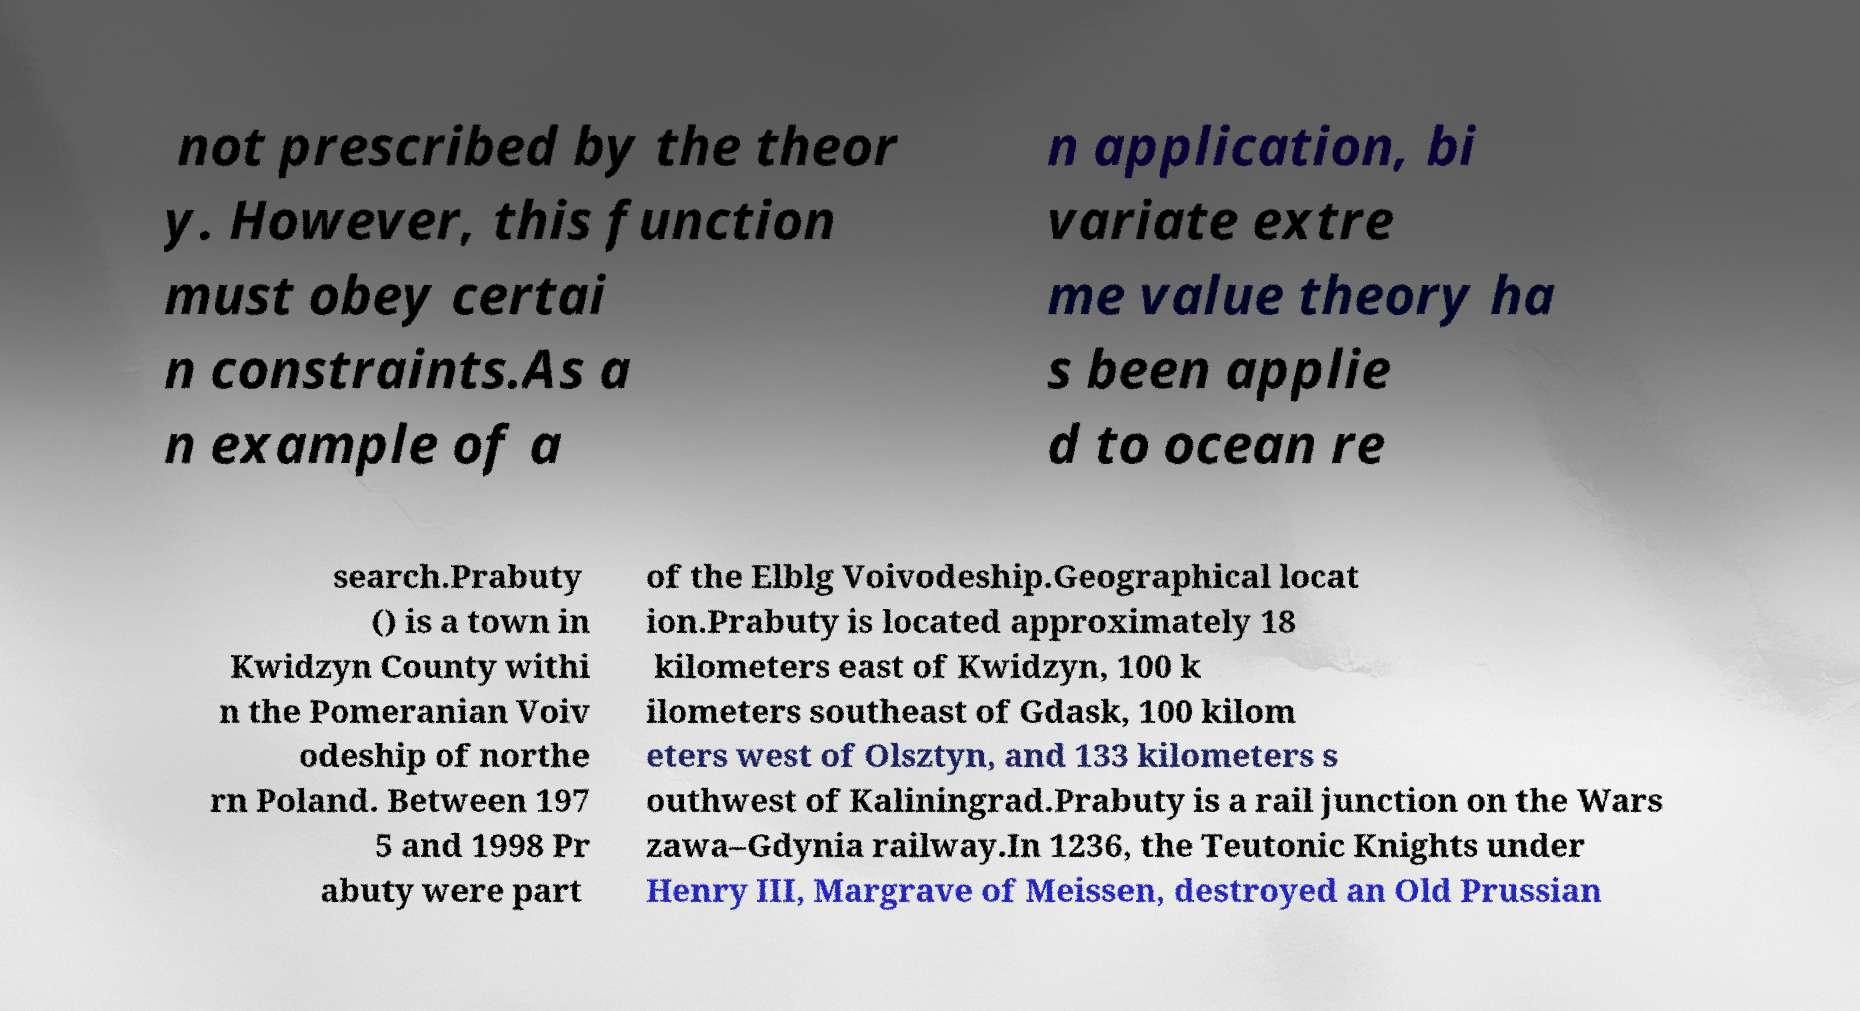For documentation purposes, I need the text within this image transcribed. Could you provide that? not prescribed by the theor y. However, this function must obey certai n constraints.As a n example of a n application, bi variate extre me value theory ha s been applie d to ocean re search.Prabuty () is a town in Kwidzyn County withi n the Pomeranian Voiv odeship of northe rn Poland. Between 197 5 and 1998 Pr abuty were part of the Elblg Voivodeship.Geographical locat ion.Prabuty is located approximately 18 kilometers east of Kwidzyn, 100 k ilometers southeast of Gdask, 100 kilom eters west of Olsztyn, and 133 kilometers s outhwest of Kaliningrad.Prabuty is a rail junction on the Wars zawa–Gdynia railway.In 1236, the Teutonic Knights under Henry III, Margrave of Meissen, destroyed an Old Prussian 